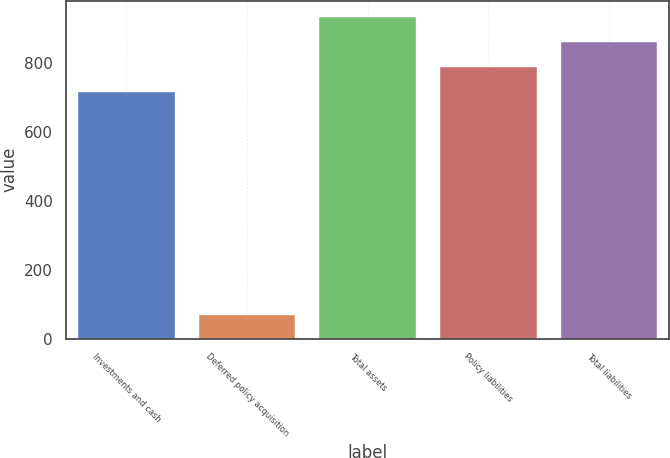Convert chart to OTSL. <chart><loc_0><loc_0><loc_500><loc_500><bar_chart><fcel>Investments and cash<fcel>Deferred policy acquisition<fcel>Total assets<fcel>Policy liabilities<fcel>Total liabilities<nl><fcel>714<fcel>69<fcel>933<fcel>787<fcel>860<nl></chart> 